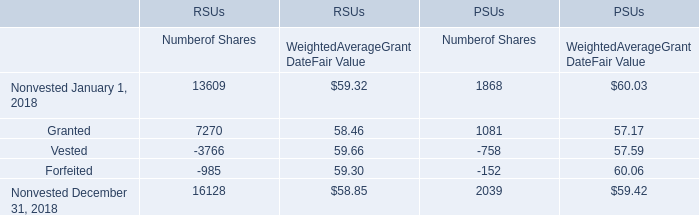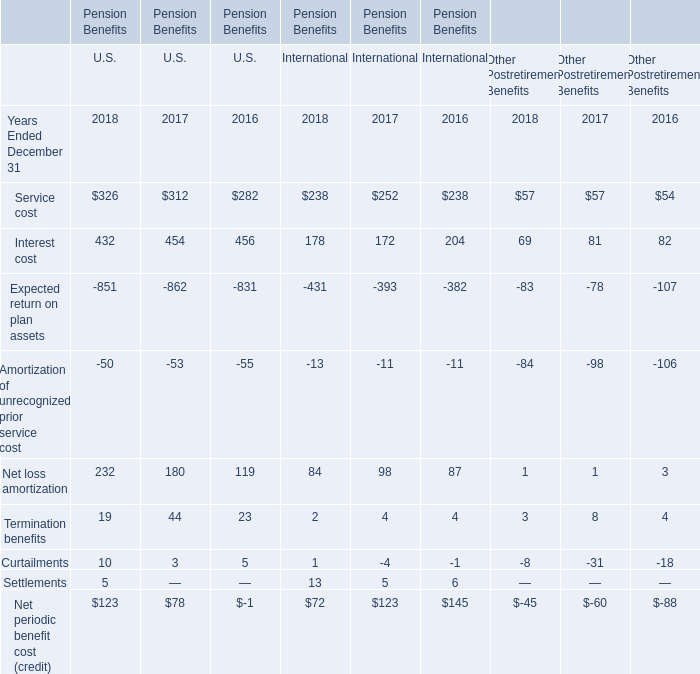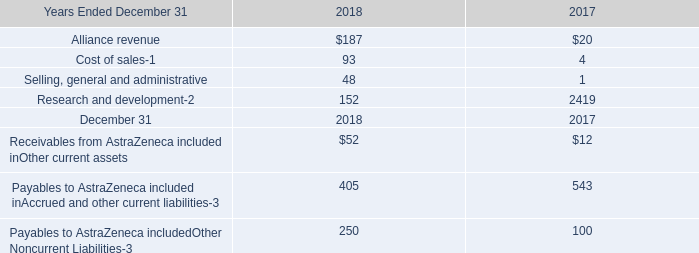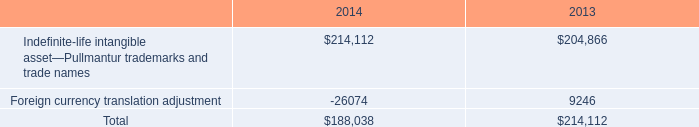for 2013 and 2014 , what is the mathematical range for foreign currency translation adjustments? 
Computations: (9246 - -26074)
Answer: 35320.0. 